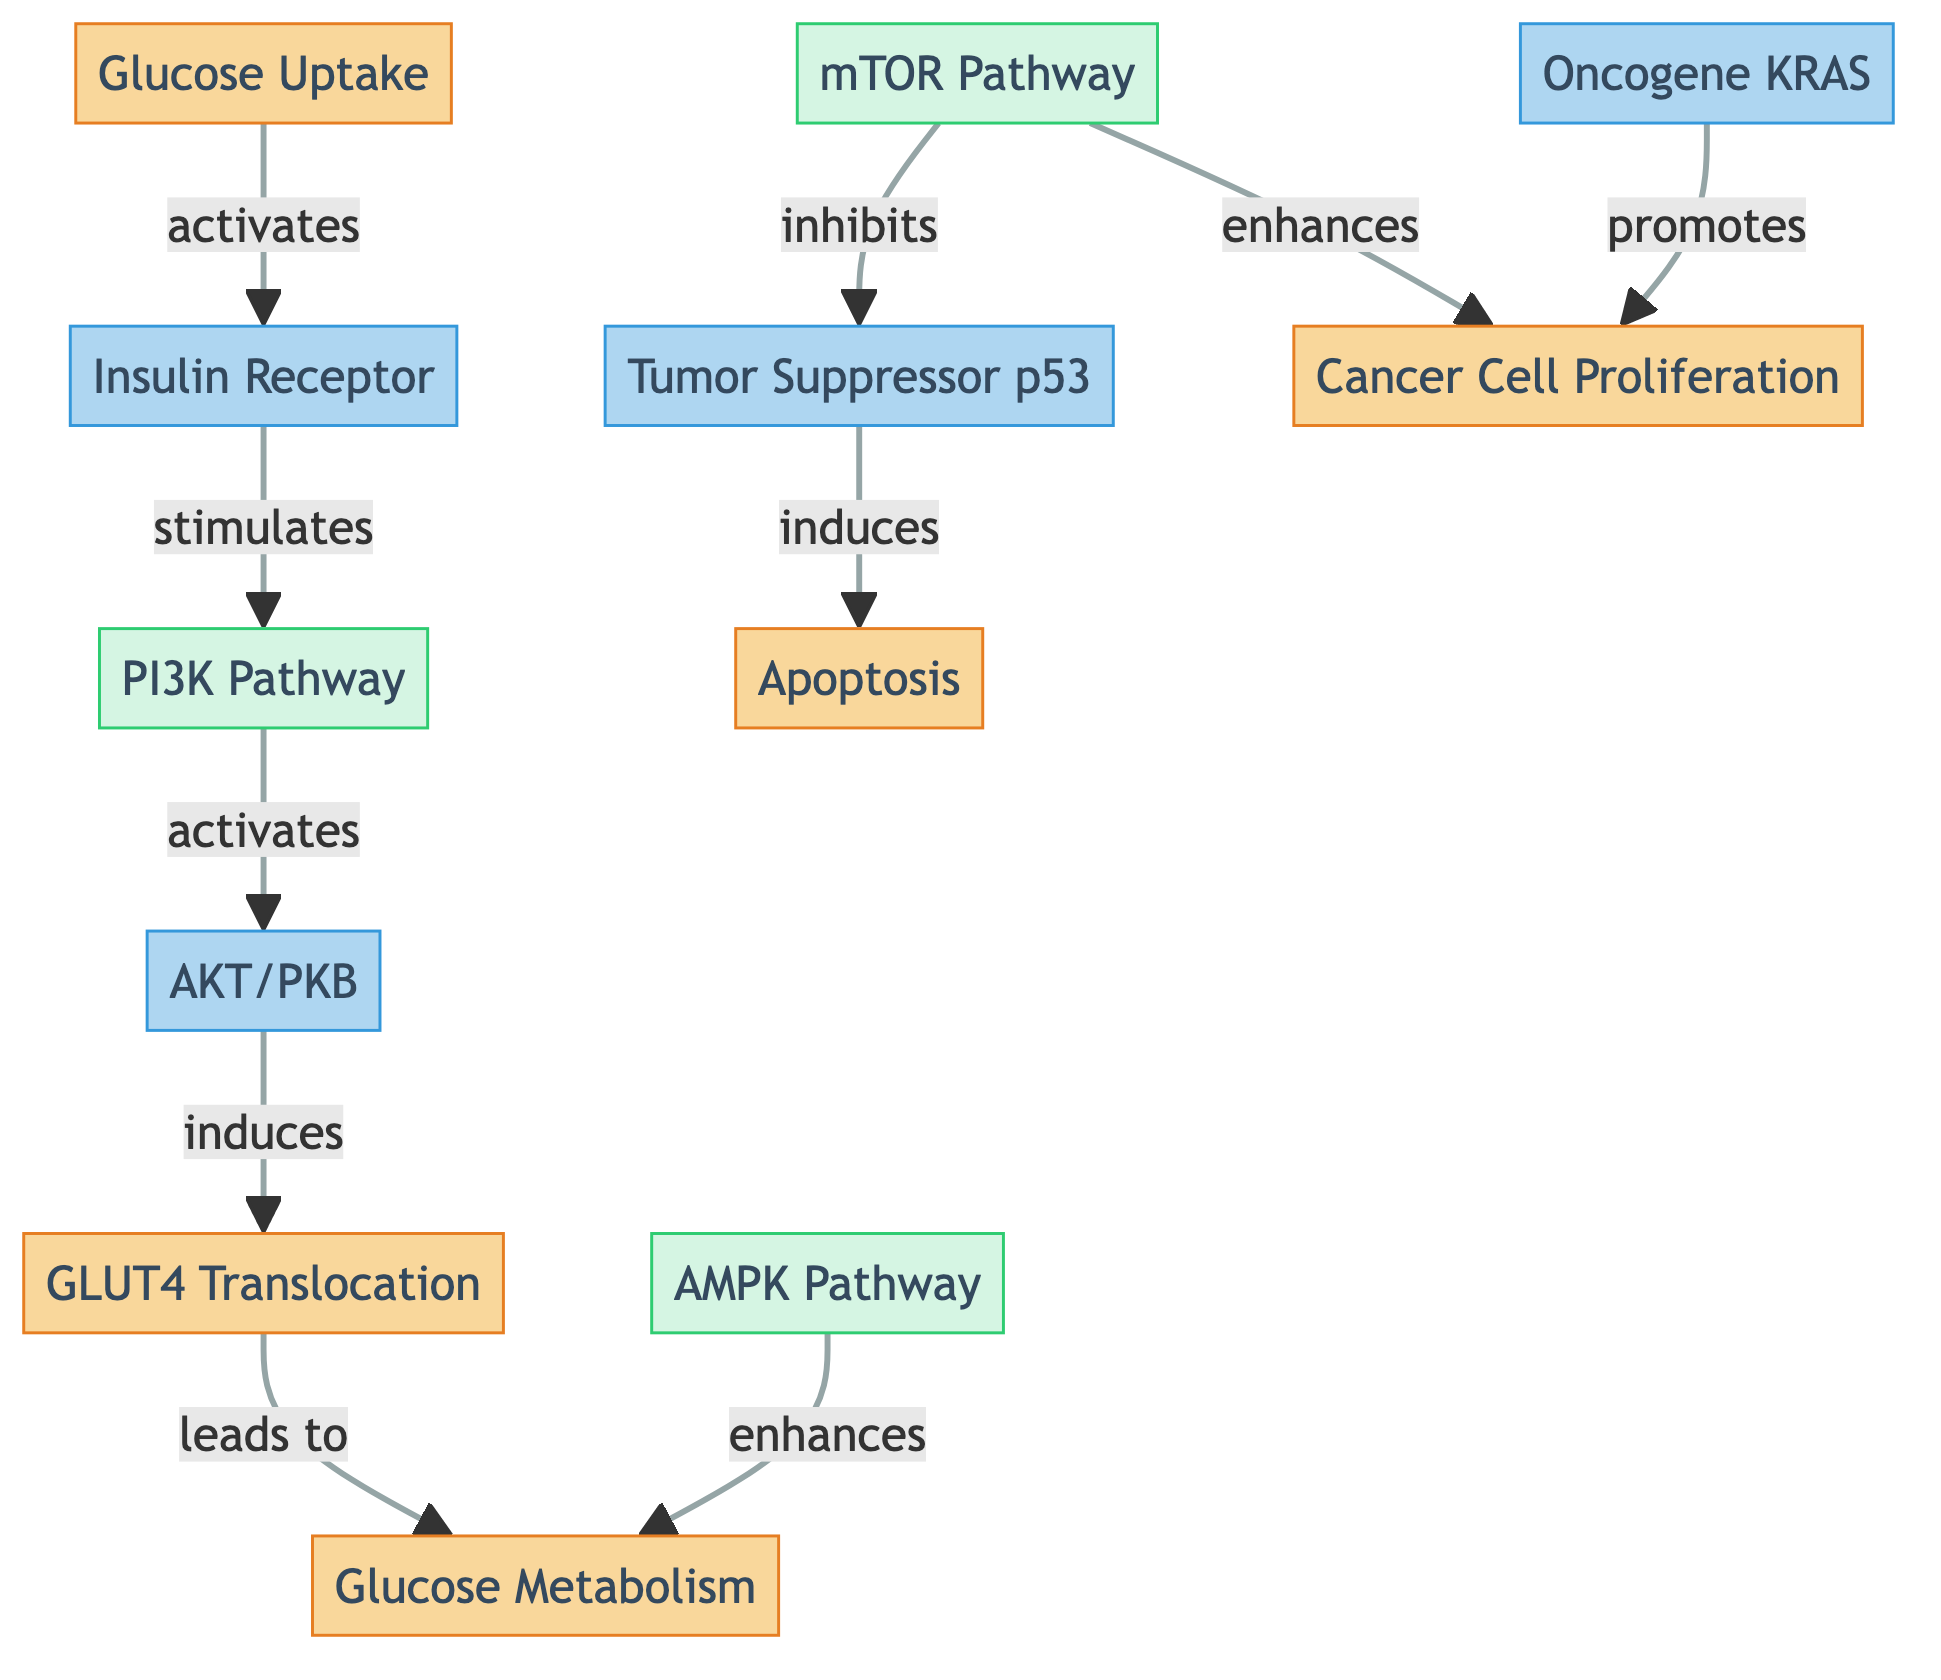What is the first process in the diagram? The first process in the diagram is labeled "Glucose Uptake," which is the starting point for the flow of information.
Answer: Glucose Uptake How many molecular components are represented in the diagram? The diagram includes four molecular components: "Insulin Receptor," "AKT/PKB," "Tumor Suppressor p53," and "Oncogene KRAS," totaling to four.
Answer: 4 What does the "Insulin Receptor" stimulate? The "Insulin Receptor" stimulates the "PI3K Pathway," indicating a direct influence in the biochemical pathway presented.
Answer: PI3K Pathway Which pathway enhances glucose metabolism? Both the "AMPK Pathway" and the "PI3K Pathway" are shown to have a positive influence on "Glucose Metabolism," indicating they enhance the process.
Answer: AMPK Pathway, PI3K Pathway What role does "Oncogene KRAS" play in the diagram? "Oncogene KRAS" promotes "Cancer Cell Proliferation," indicating its function in stimulating the growth of cancer cells.
Answer: Promotes Cancer Cell Proliferation What does the "mTOR Pathway" inhibit? The "mTOR Pathway" inhibits "Tumor Suppressor p53," which suggests a negative regulatory effect on this critical tumor suppressor.
Answer: Tumor Suppressor p53 Which process follows the "AKT/PKB" activation? After "AKT/PKB" is activated, it induces "GLUT4 Translocation," showing a sequential relationship where one leads to another in glucose metabolism.
Answer: GLUT4 Translocation How many processes are there in total? The total number of processes represented in the diagram is five: "Glucose Uptake," "GLUT4 Translocation," "Glucose Metabolism," "Apoptosis," and "Cancer Cell Proliferation."
Answer: 5 